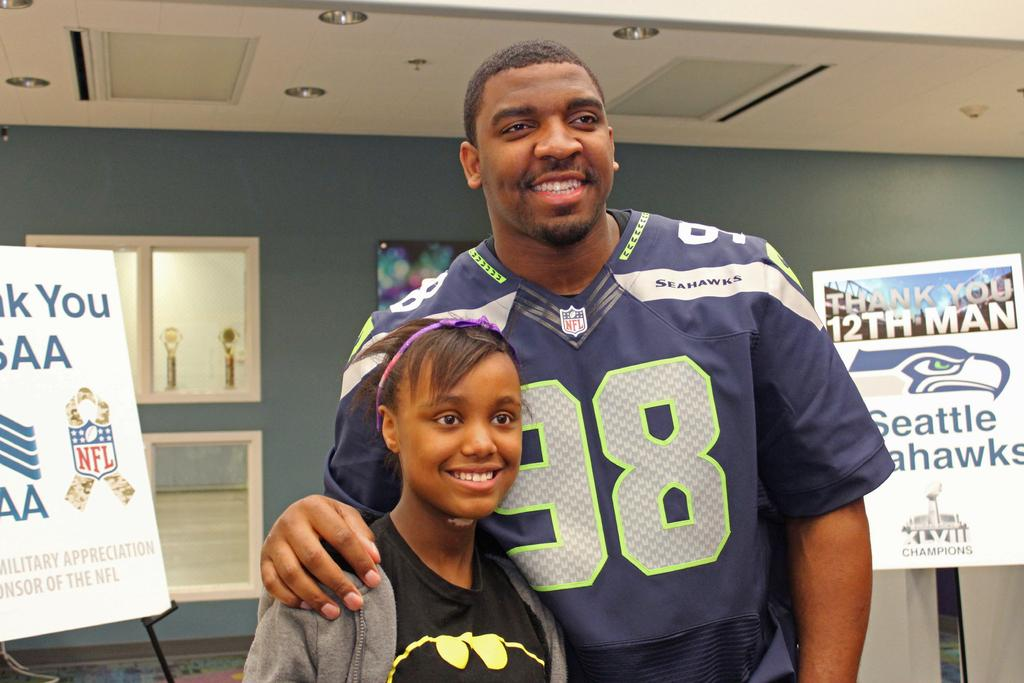Provide a one-sentence caption for the provided image. Player wearing jersey 98 taking a picture with a girl. 